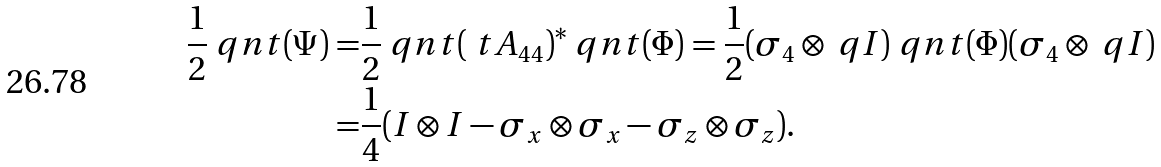Convert formula to latex. <formula><loc_0><loc_0><loc_500><loc_500>\frac { 1 } { 2 } \ q n t ( \Psi ) = & \frac { 1 } { 2 } \ q n t ( \ t A _ { 4 4 } ) ^ { * } \ q n t ( \Phi ) = \frac { 1 } { 2 } ( \sigma _ { 4 } \otimes \ q I ) \ q n t ( \Phi ) ( \sigma _ { 4 } \otimes \ q I ) \\ = & \frac { 1 } { 4 } ( I \otimes I - \sigma _ { x } \otimes \sigma _ { x } - \sigma _ { z } \otimes \sigma _ { z } ) .</formula> 